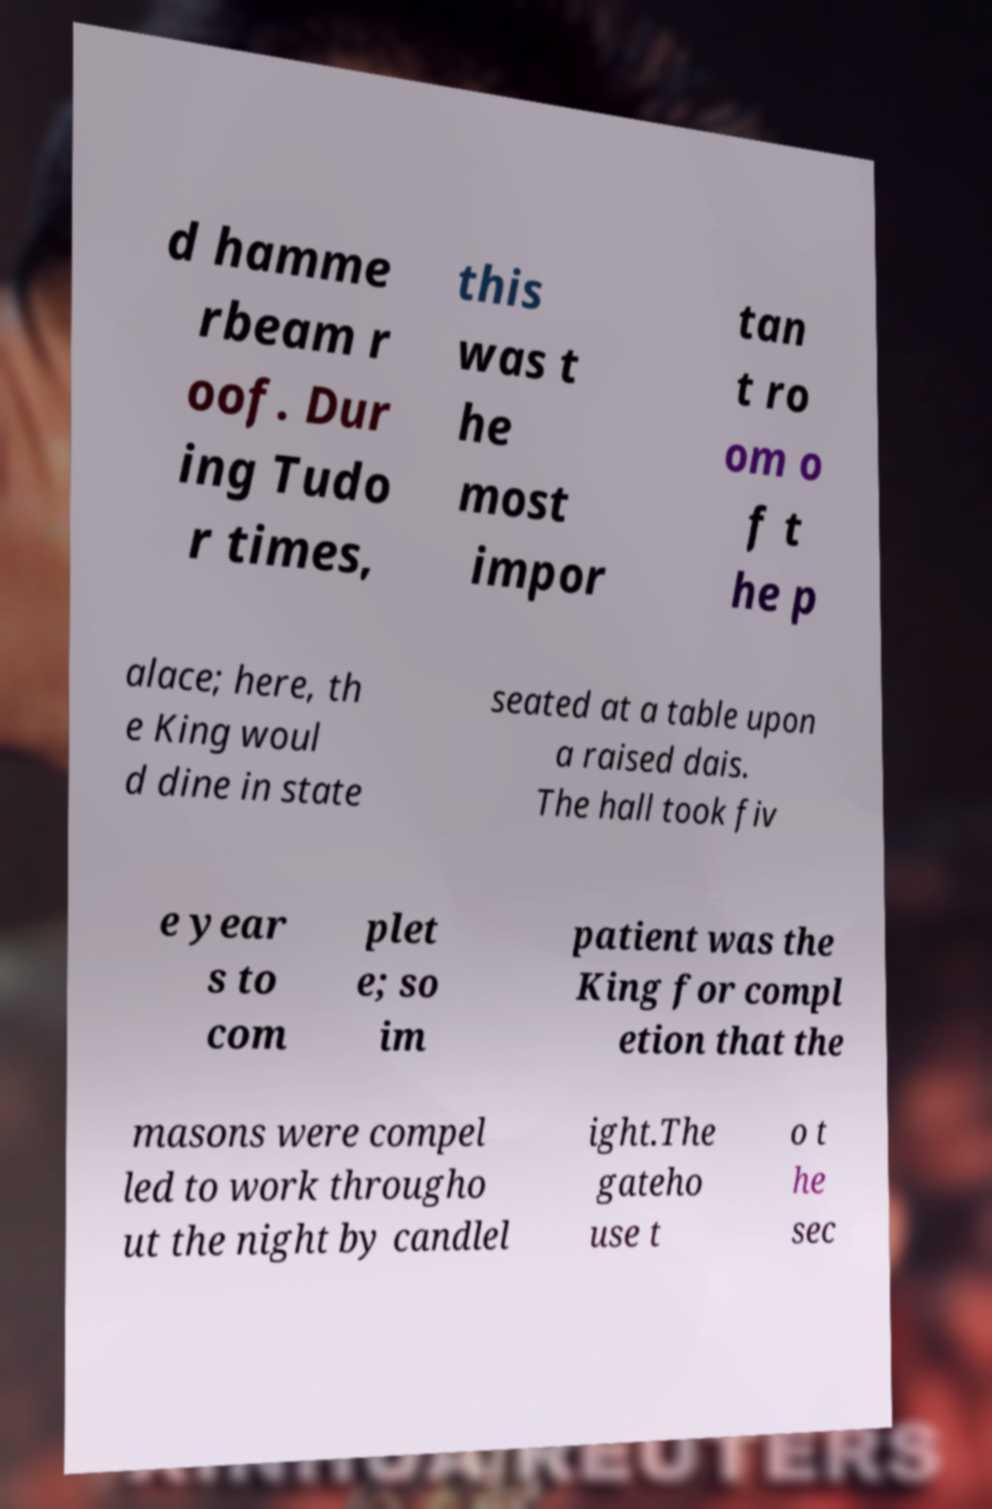For documentation purposes, I need the text within this image transcribed. Could you provide that? d hamme rbeam r oof. Dur ing Tudo r times, this was t he most impor tan t ro om o f t he p alace; here, th e King woul d dine in state seated at a table upon a raised dais. The hall took fiv e year s to com plet e; so im patient was the King for compl etion that the masons were compel led to work througho ut the night by candlel ight.The gateho use t o t he sec 